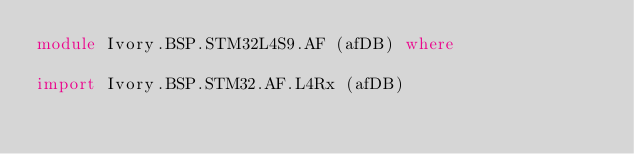<code> <loc_0><loc_0><loc_500><loc_500><_Haskell_>module Ivory.BSP.STM32L4S9.AF (afDB) where

import Ivory.BSP.STM32.AF.L4Rx (afDB)
</code> 